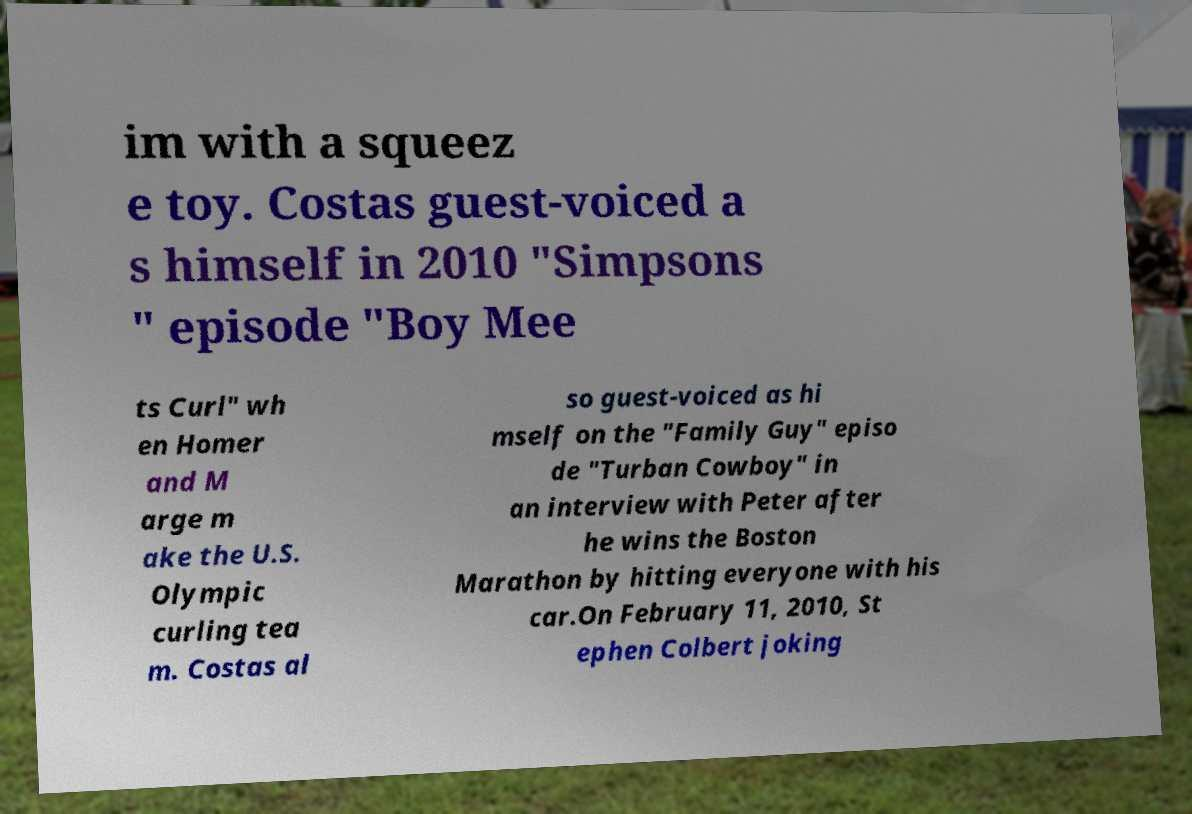What messages or text are displayed in this image? I need them in a readable, typed format. im with a squeez e toy. Costas guest-voiced a s himself in 2010 "Simpsons " episode "Boy Mee ts Curl" wh en Homer and M arge m ake the U.S. Olympic curling tea m. Costas al so guest-voiced as hi mself on the "Family Guy" episo de "Turban Cowboy" in an interview with Peter after he wins the Boston Marathon by hitting everyone with his car.On February 11, 2010, St ephen Colbert joking 